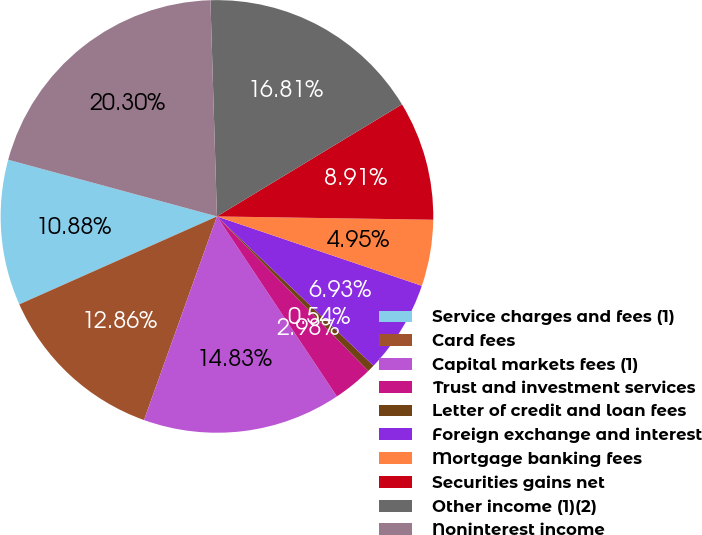<chart> <loc_0><loc_0><loc_500><loc_500><pie_chart><fcel>Service charges and fees (1)<fcel>Card fees<fcel>Capital markets fees (1)<fcel>Trust and investment services<fcel>Letter of credit and loan fees<fcel>Foreign exchange and interest<fcel>Mortgage banking fees<fcel>Securities gains net<fcel>Other income (1)(2)<fcel>Noninterest income<nl><fcel>10.88%<fcel>12.86%<fcel>14.83%<fcel>2.98%<fcel>0.54%<fcel>6.93%<fcel>4.95%<fcel>8.91%<fcel>16.81%<fcel>20.3%<nl></chart> 